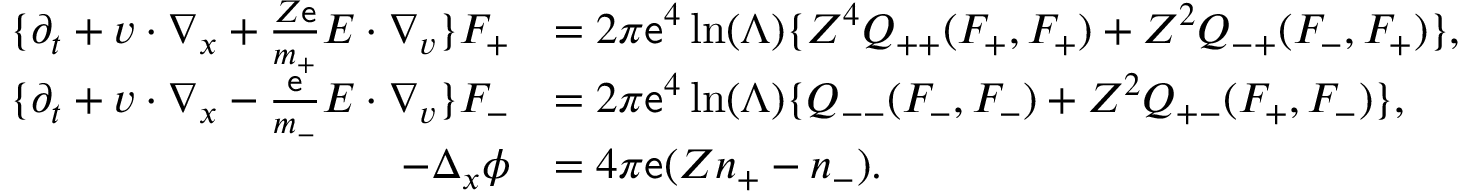<formula> <loc_0><loc_0><loc_500><loc_500>\begin{array} { r l } { \{ \partial _ { t } + v \cdot \nabla _ { x } + \frac { Z \mathsf e } { m _ { + } } E \cdot \nabla _ { v } \} F _ { + } } & { = 2 \pi \mathsf e ^ { 4 } \ln ( \Lambda ) \{ Z ^ { 4 } Q _ { + + } ( F _ { + } , F _ { + } ) + Z ^ { 2 } Q _ { - + } ( F _ { - } , F _ { + } ) \} , } \\ { \{ \partial _ { t } + v \cdot \nabla _ { x } - \frac { \mathsf e } { m _ { - } } E \cdot \nabla _ { v } \} F _ { - } } & { = 2 \pi \mathsf e ^ { 4 } \ln ( \Lambda ) \{ Q _ { - - } ( F _ { - } , F _ { - } ) + Z ^ { 2 } Q _ { + - } ( F _ { + } , F _ { - } ) \} , } \\ { - \Delta _ { x } \phi } & { = 4 \pi \mathsf e ( Z n _ { + } - n _ { - } ) . } \end{array}</formula> 